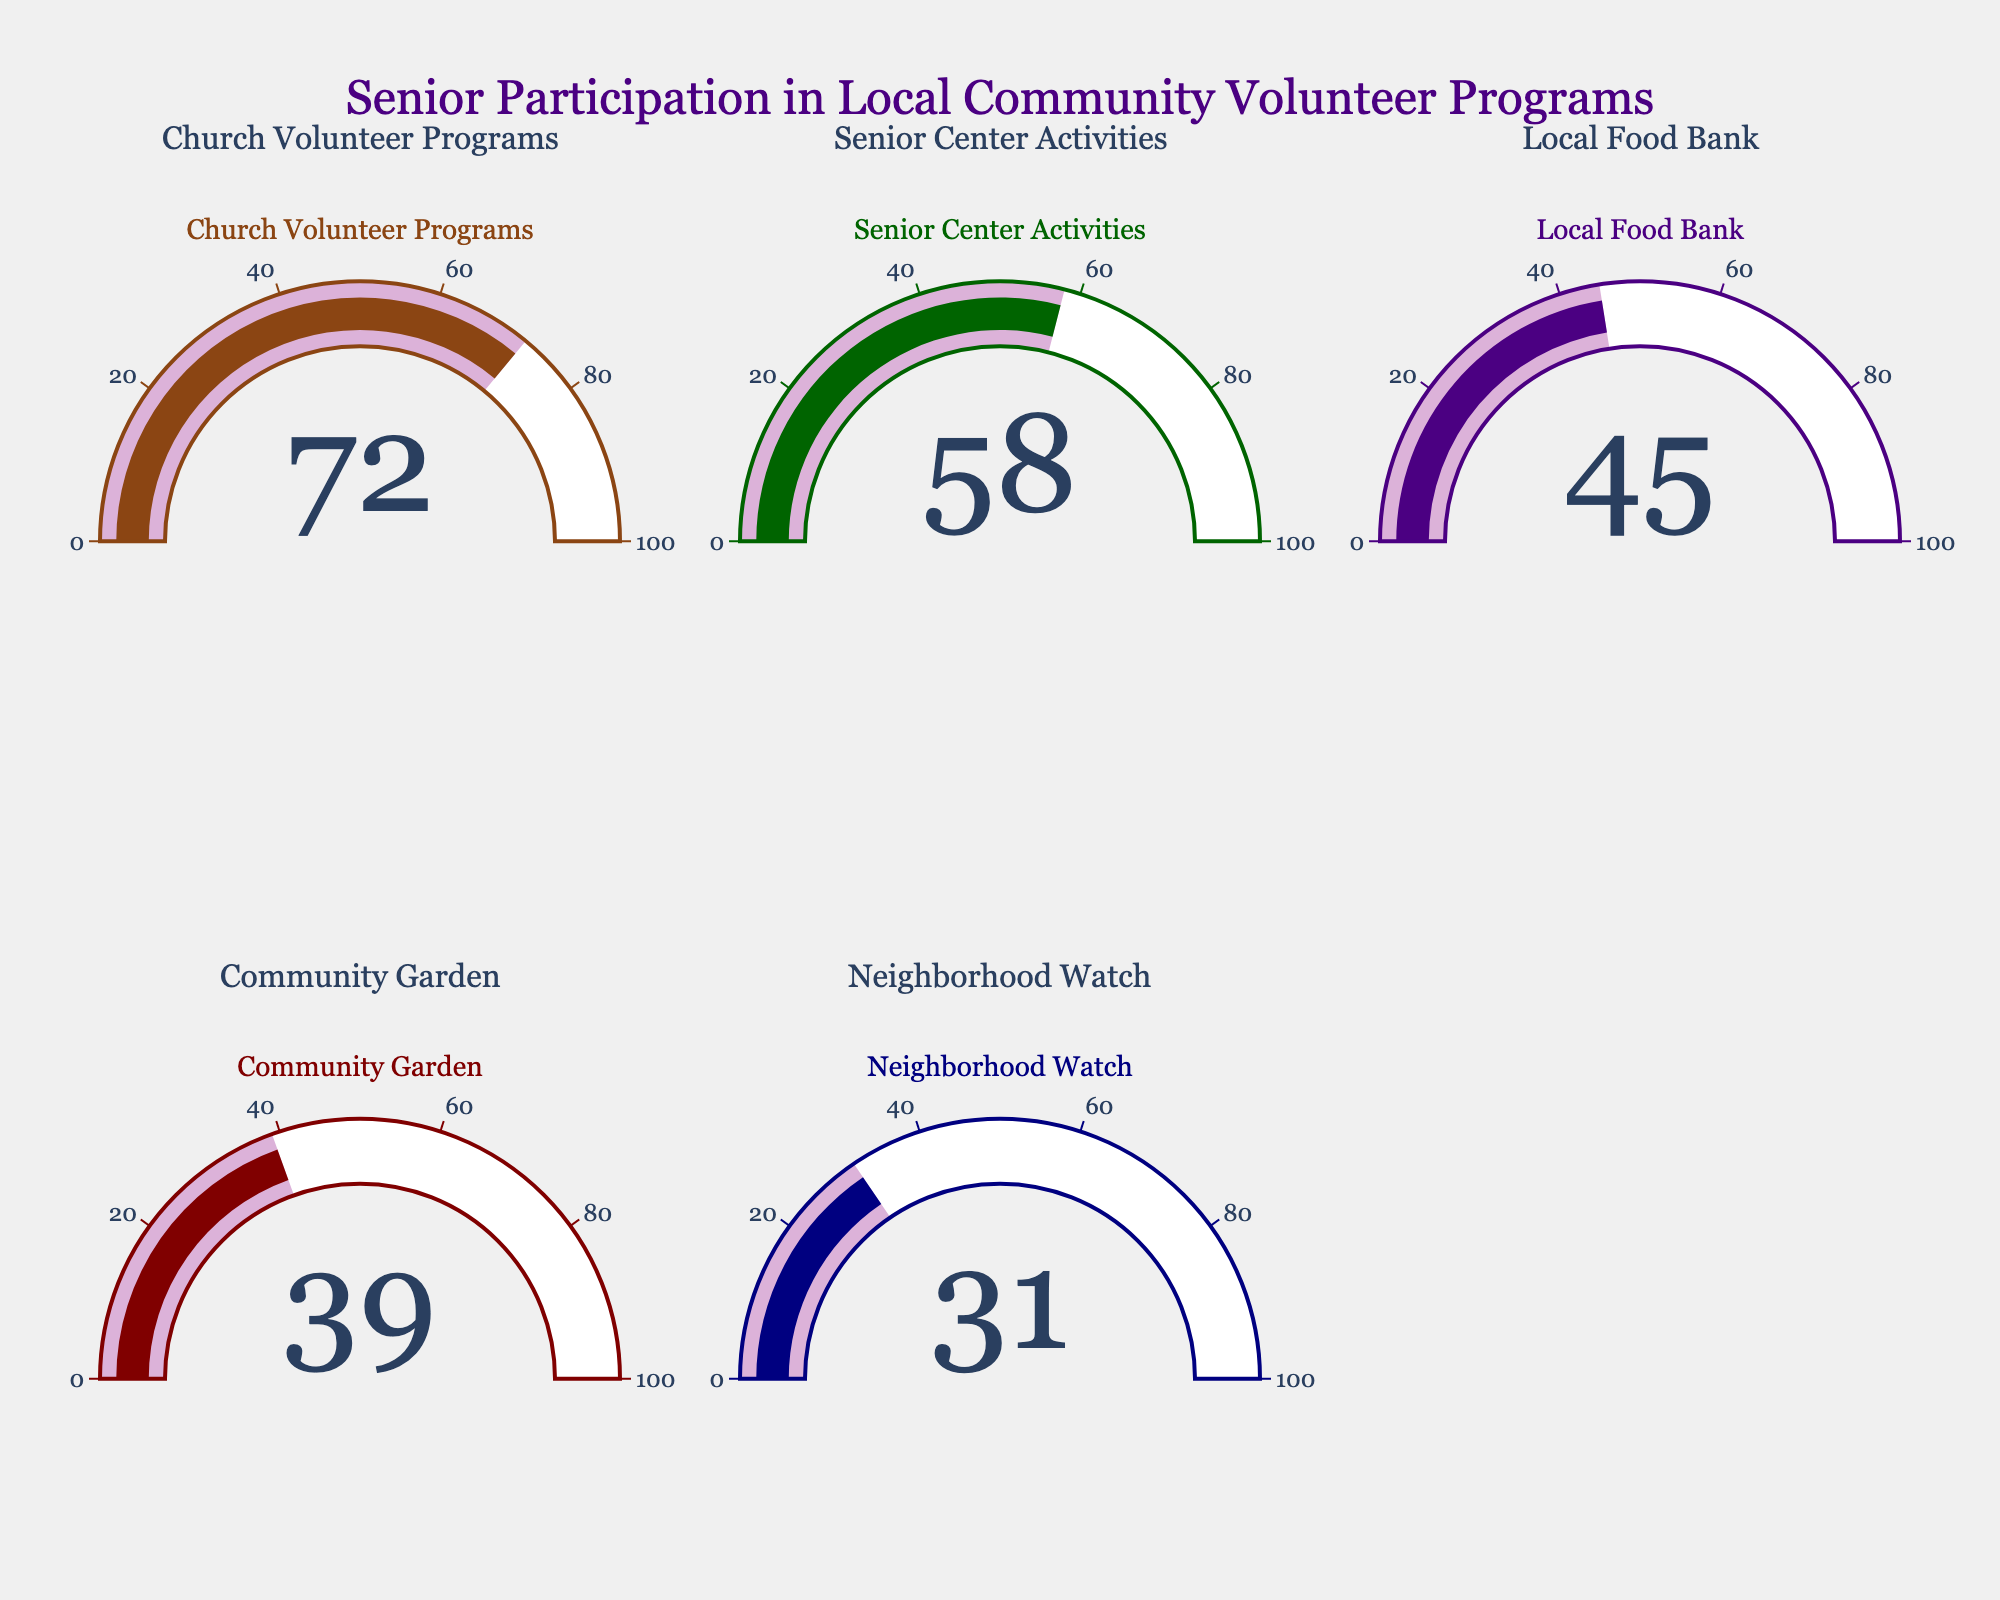What is the participation rate for Church Volunteer Programs? The gauge for Church Volunteer Programs shows a value of 72, indicating the participation rate.
Answer: 72 Which program has the lowest participation rate? The gauge for Neighborhood Watch shows the lowest value of 31 among all the programs listed in the figure.
Answer: Neighborhood Watch What is the difference in participation rates between Senior Center Activities and Local Food Bank programs? The participation rate for Senior Center Activities is 58, and for Local Food Bank, it is 45. The difference is calculated as 58 - 45.
Answer: 13 Which program has a participation rate closest to 50%? Comparing the participation rates, Local Food Bank has a rate closest to 50% with a value of 45.
Answer: Local Food Bank What is the average participation rate across all the programs? Adding up all participation rates: 72 + 58 + 45 + 39 + 31 = 245. There are 5 programs, so the average is 245/5.
Answer: 49 How much higher is the participation rate for Church Volunteer Programs compared to Community Garden? The participation rate for Church Volunteer Programs is 72, and for Community Garden, it is 39. The difference is calculated as 72 - 39.
Answer: 33 Which two programs have a combined participation rate of more than 100%? Church Volunteer Programs (72) and Senior Center Activities (58) together have a combined rate of 72 + 58, which is more than 100%.
Answer: Church Volunteer Programs and Senior Center Activities What percentage of the highest participation rate is the Neighborhood Watch's rate? The highest participation rate is 72 (Church Volunteer Programs). The Neighborhood Watch rate is 31. The percentage is calculated by (31/72) * 100.
Answer: Approximately 43% What is the median participation rate among the programs listed? Ordering the participation rates from lowest to highest: 31, 39, 45, 58, 72. The middle value (median) is 45.
Answer: 45 Which program has the second lowest participation rate? Sorting the participation rates from lowest to second lowest: Neighborhood Watch (31), Community Garden (39).
Answer: Community Garden 